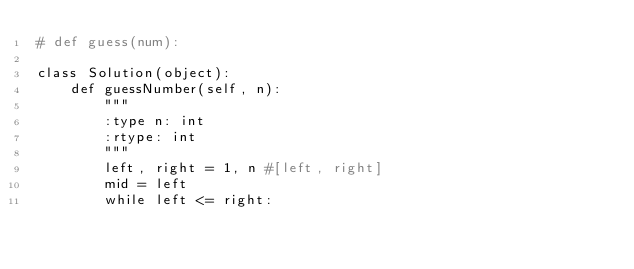<code> <loc_0><loc_0><loc_500><loc_500><_Python_># def guess(num):

class Solution(object):
    def guessNumber(self, n):
        """
        :type n: int
        :rtype: int
        """
        left, right = 1, n #[left, right]
        mid = left
        while left <= right:</code> 